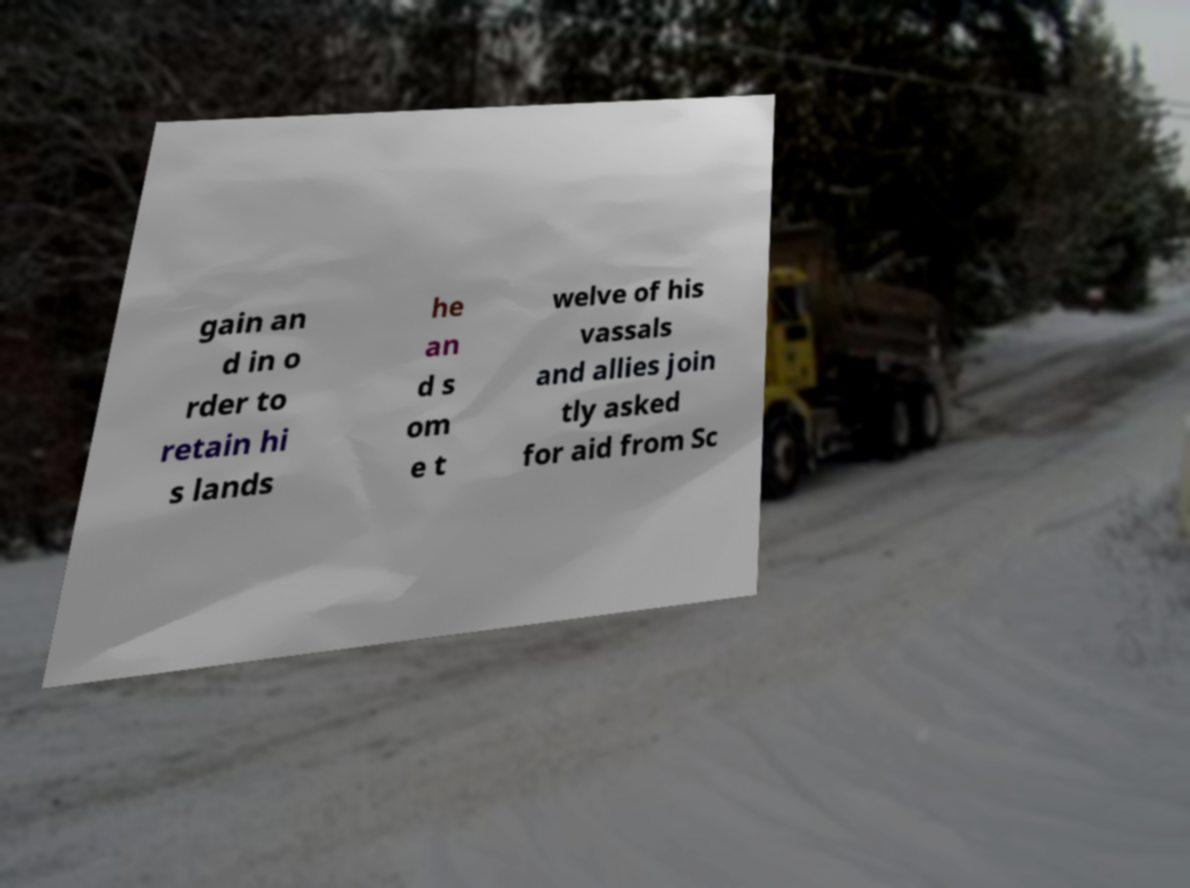For documentation purposes, I need the text within this image transcribed. Could you provide that? gain an d in o rder to retain hi s lands he an d s om e t welve of his vassals and allies join tly asked for aid from Sc 